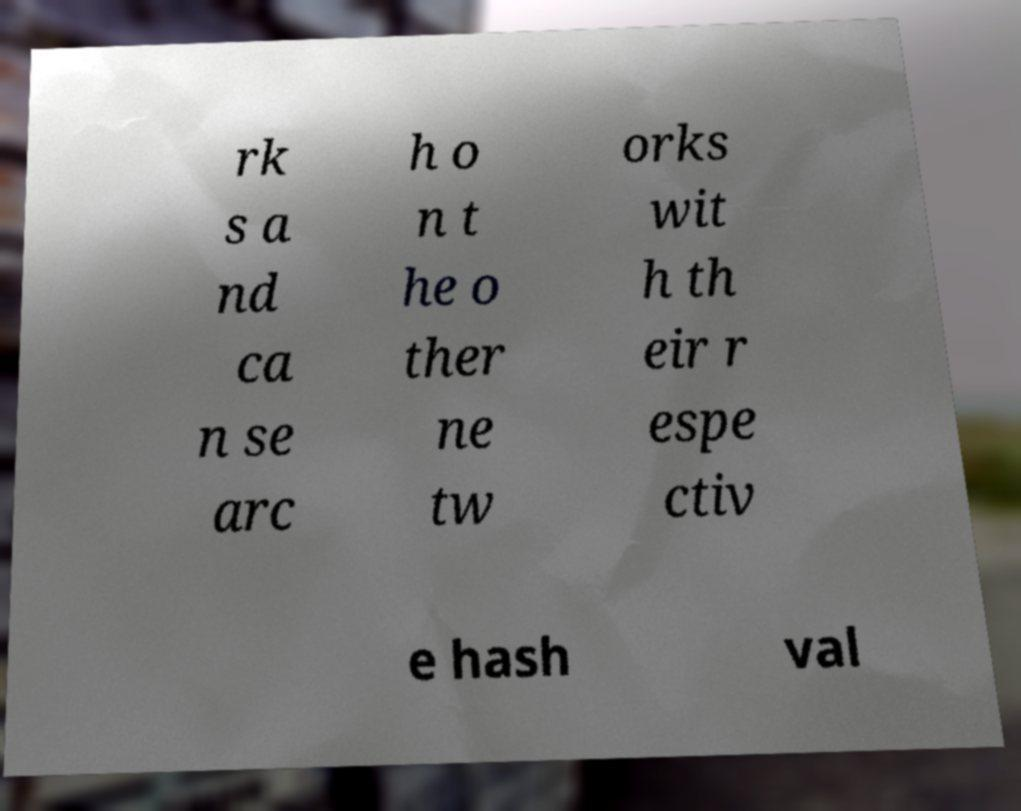There's text embedded in this image that I need extracted. Can you transcribe it verbatim? rk s a nd ca n se arc h o n t he o ther ne tw orks wit h th eir r espe ctiv e hash val 